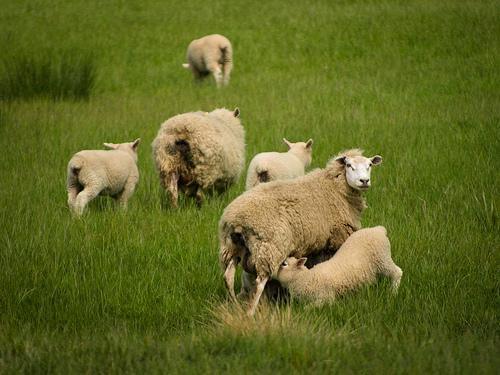How many sheep are there?
Give a very brief answer. 6. 